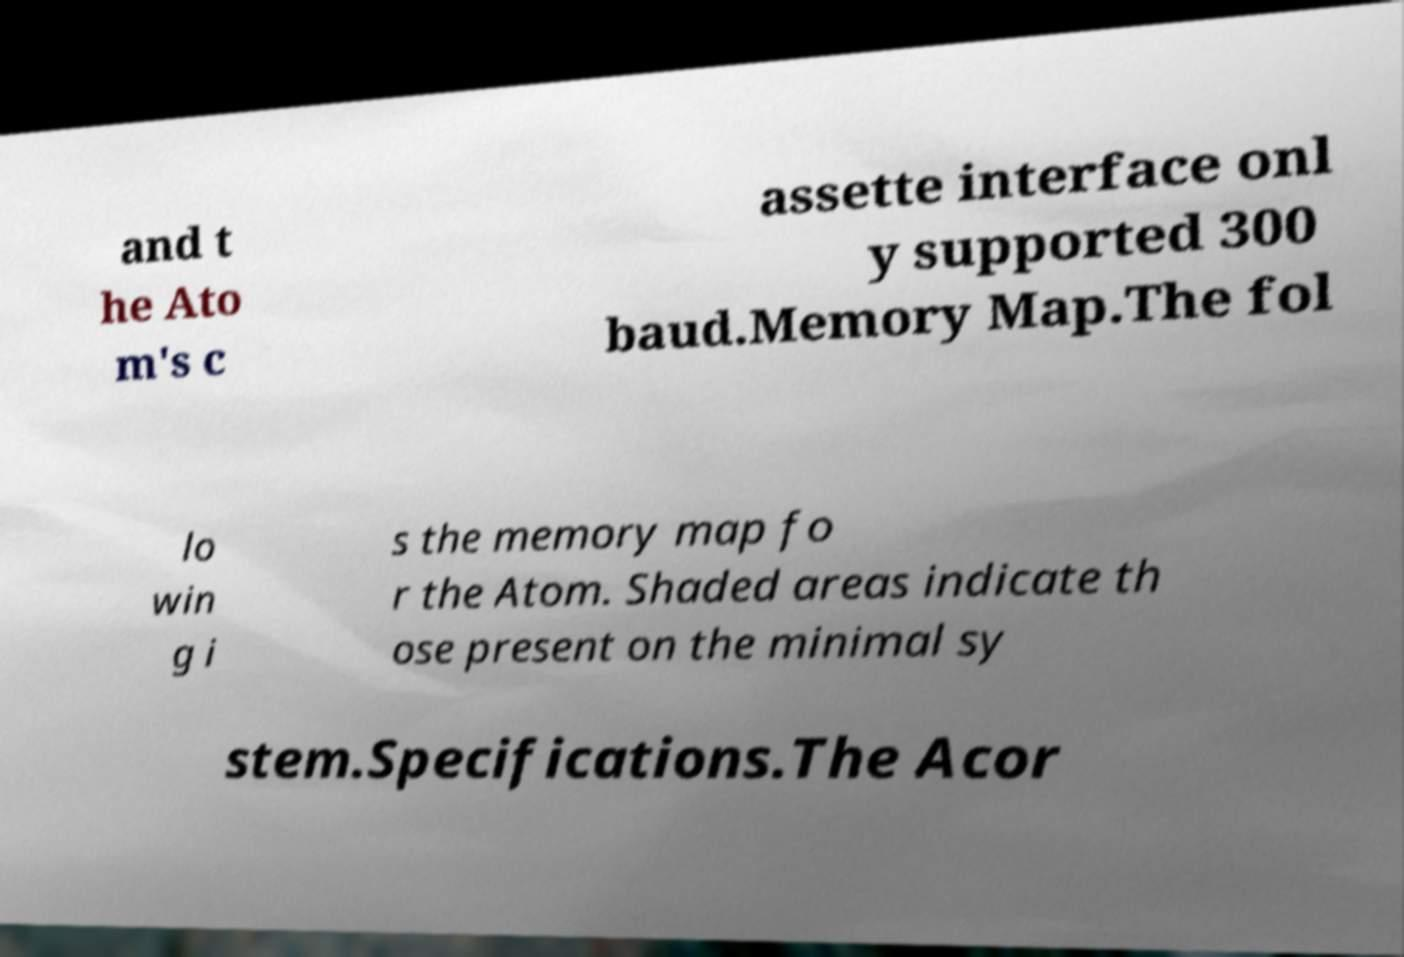For documentation purposes, I need the text within this image transcribed. Could you provide that? and t he Ato m's c assette interface onl y supported 300 baud.Memory Map.The fol lo win g i s the memory map fo r the Atom. Shaded areas indicate th ose present on the minimal sy stem.Specifications.The Acor 